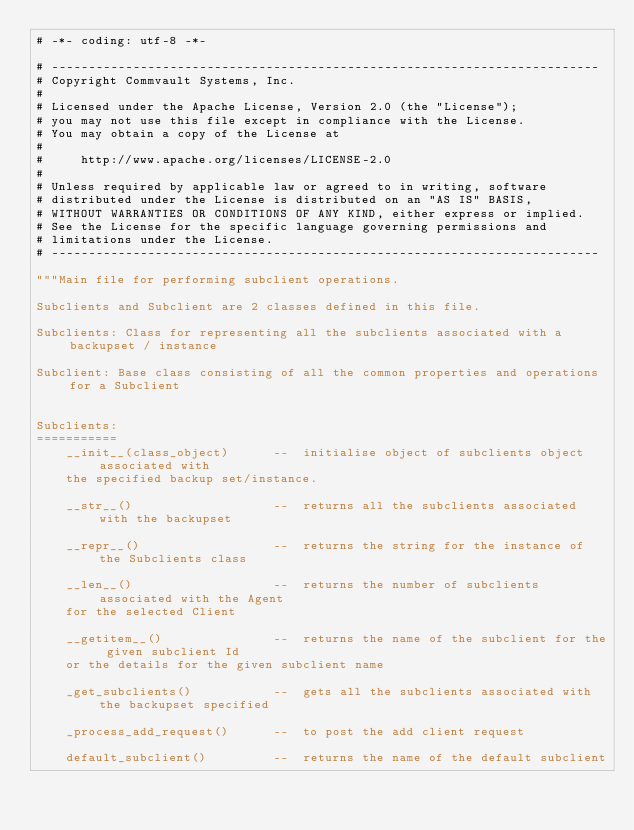<code> <loc_0><loc_0><loc_500><loc_500><_Python_># -*- coding: utf-8 -*-

# --------------------------------------------------------------------------
# Copyright Commvault Systems, Inc.
#
# Licensed under the Apache License, Version 2.0 (the "License");
# you may not use this file except in compliance with the License.
# You may obtain a copy of the License at
#
#     http://www.apache.org/licenses/LICENSE-2.0
#
# Unless required by applicable law or agreed to in writing, software
# distributed under the License is distributed on an "AS IS" BASIS,
# WITHOUT WARRANTIES OR CONDITIONS OF ANY KIND, either express or implied.
# See the License for the specific language governing permissions and
# limitations under the License.
# --------------------------------------------------------------------------

"""Main file for performing subclient operations.

Subclients and Subclient are 2 classes defined in this file.

Subclients: Class for representing all the subclients associated with a backupset / instance

Subclient: Base class consisting of all the common properties and operations for a Subclient


Subclients:
===========
    __init__(class_object)      --  initialise object of subclients object associated with
    the specified backup set/instance.

    __str__()                   --  returns all the subclients associated with the backupset

    __repr__()                  --  returns the string for the instance of the Subclients class

    __len__()                   --  returns the number of subclients associated with the Agent
    for the selected Client

    __getitem__()               --  returns the name of the subclient for the given subclient Id
    or the details for the given subclient name

    _get_subclients()           --  gets all the subclients associated with the backupset specified

    _process_add_request()      --  to post the add client request

    default_subclient()         --  returns the name of the default subclient
</code> 